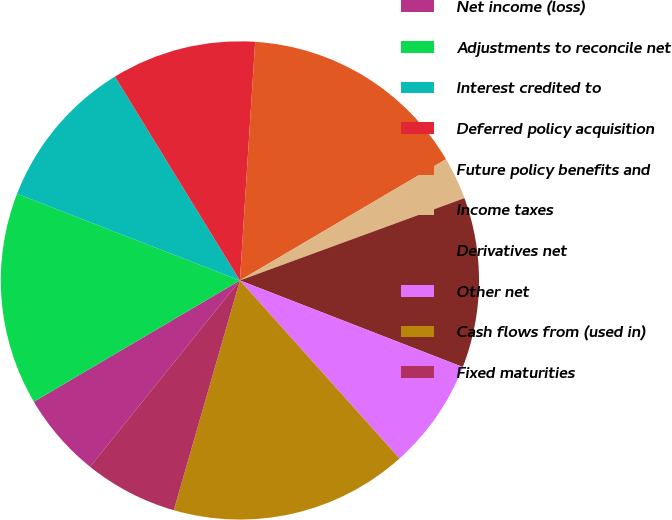<chart> <loc_0><loc_0><loc_500><loc_500><pie_chart><fcel>Net income (loss)<fcel>Adjustments to reconcile net<fcel>Interest credited to<fcel>Deferred policy acquisition<fcel>Future policy benefits and<fcel>Income taxes<fcel>Derivatives net<fcel>Other net<fcel>Cash flows from (used in)<fcel>Fixed maturities<nl><fcel>5.75%<fcel>14.37%<fcel>10.34%<fcel>9.77%<fcel>15.52%<fcel>2.87%<fcel>11.49%<fcel>7.47%<fcel>16.09%<fcel>6.32%<nl></chart> 